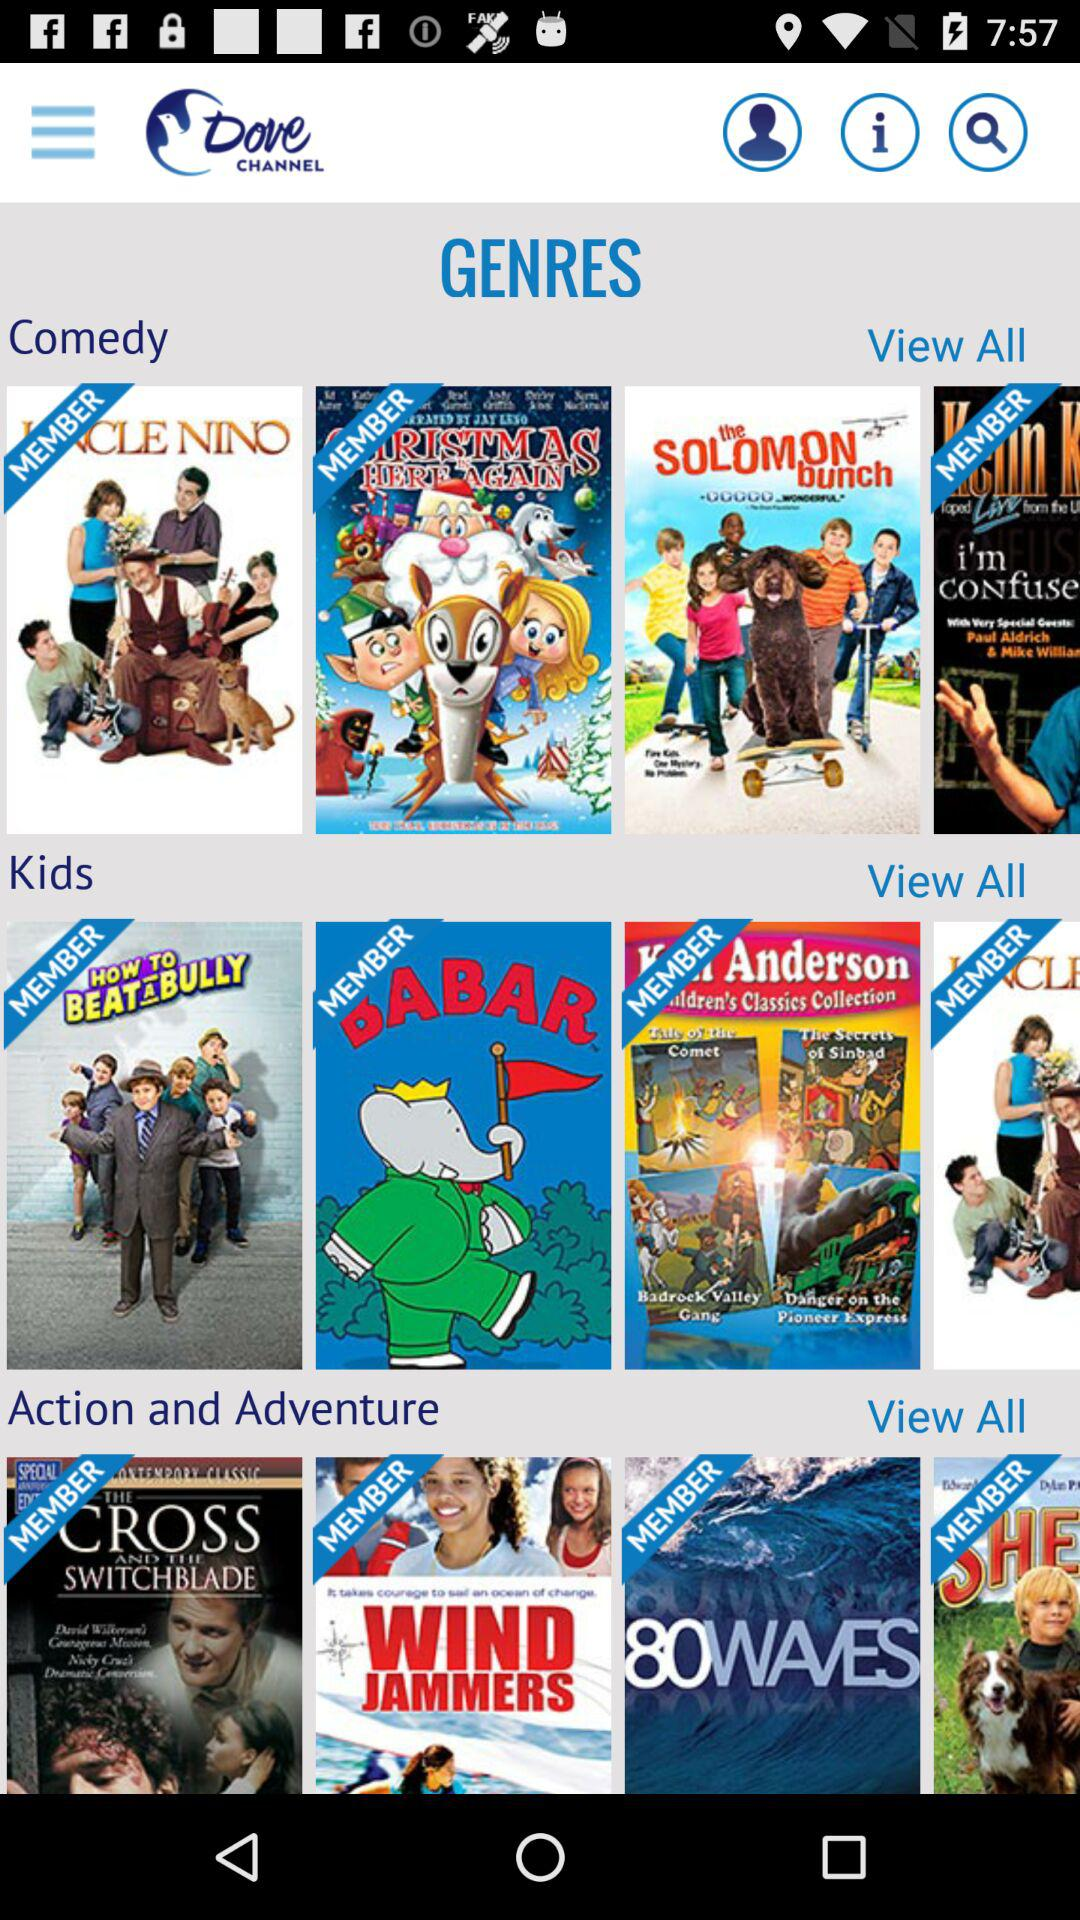What are the names of the few movies added to the comedy section? The names of the few movies are "CHRISTMAS IS HERE AGAIN" and "the SOLOMON bunch". 